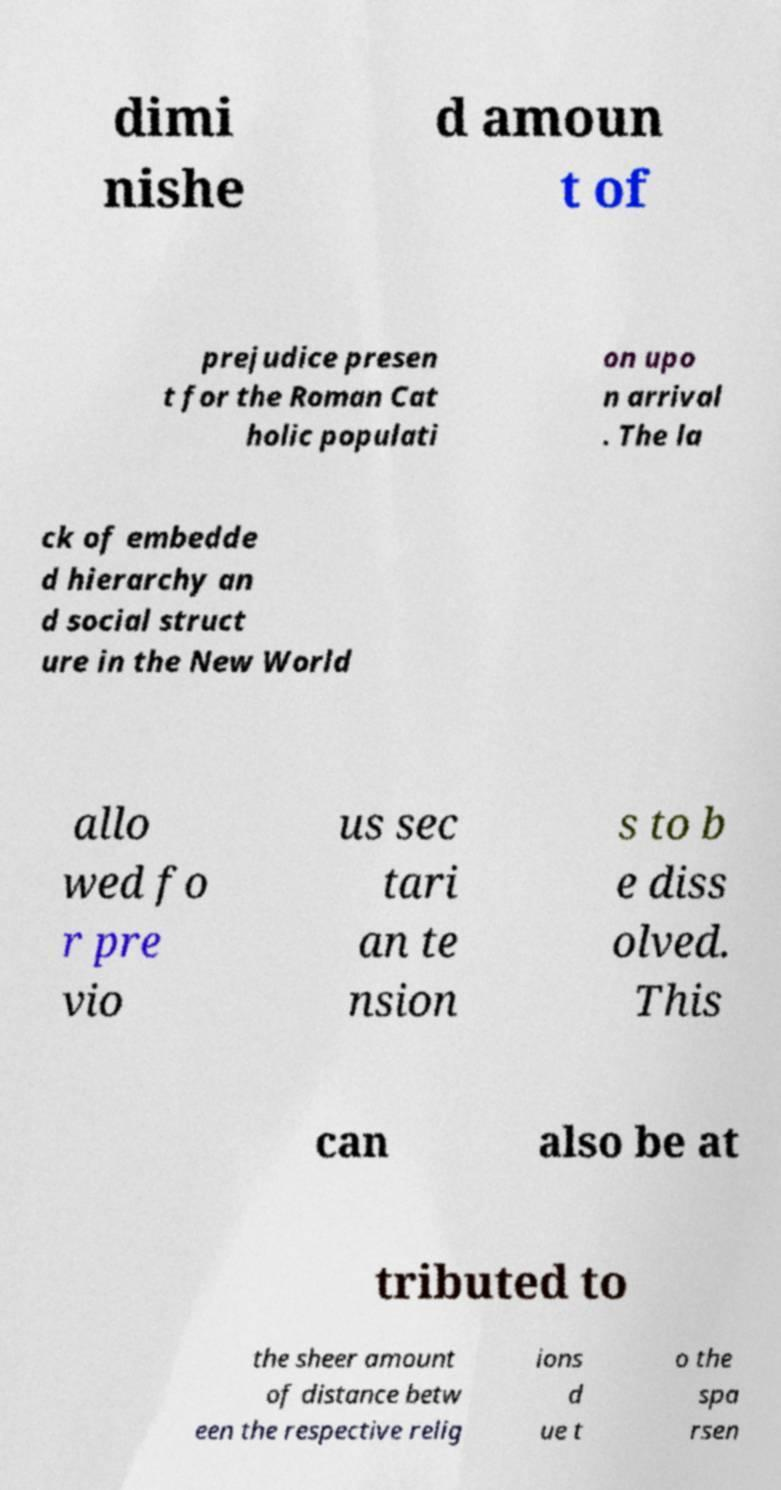Please read and relay the text visible in this image. What does it say? dimi nishe d amoun t of prejudice presen t for the Roman Cat holic populati on upo n arrival . The la ck of embedde d hierarchy an d social struct ure in the New World allo wed fo r pre vio us sec tari an te nsion s to b e diss olved. This can also be at tributed to the sheer amount of distance betw een the respective relig ions d ue t o the spa rsen 